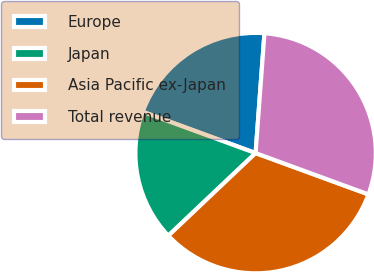<chart> <loc_0><loc_0><loc_500><loc_500><pie_chart><fcel>Europe<fcel>Japan<fcel>Asia Pacific ex-Japan<fcel>Total revenue<nl><fcel>20.59%<fcel>17.65%<fcel>32.35%<fcel>29.41%<nl></chart> 